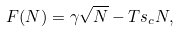<formula> <loc_0><loc_0><loc_500><loc_500>F ( N ) = \gamma \sqrt { N } - T s _ { c } N ,</formula> 